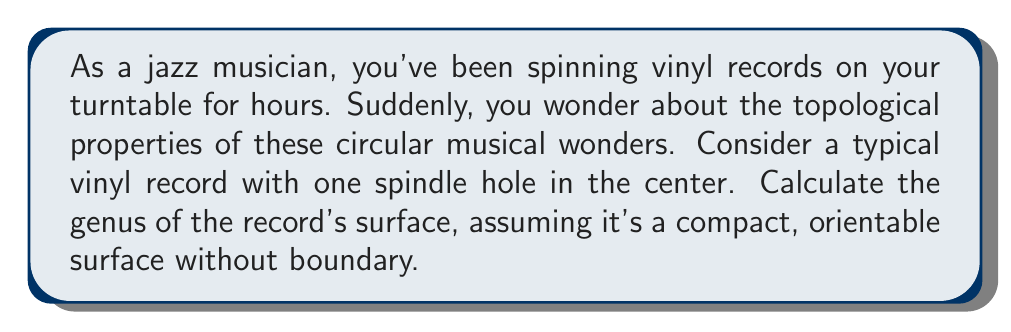Provide a solution to this math problem. To calculate the genus of the vinyl record's surface, we need to consider its topological properties:

1. The record is essentially a flat disk with a hole in the center.

2. In topology, this shape is equivalent to an annulus (a ring-shaped surface).

3. The genus of a surface is the maximum number of simple closed curves that can be drawn on the surface without separating it.

4. For a compact, orientable surface without boundary, the genus $g$ is related to the Euler characteristic $\chi$ by the formula:

   $$\chi = 2 - 2g$$

5. For an annulus, the Euler characteristic is 0. This is because:
   - It has 1 face (the surface itself)
   - It has 2 edges (the outer and inner circles)
   - It has 0 vertices

   $$\chi = V - E + F = 0 - 2 + 1 = -1$$

6. Substituting this into our formula:

   $$0 = 2 - 2g$$

7. Solving for $g$:

   $$2g = 2$$
   $$g = 1$$

Therefore, the genus of the vinyl record's surface is 1.

This means you can draw one simple closed curve (imagine a line from the outer edge to the inner hole and back to the starting point) without separating the surface, but a second such curve would divide the surface into two separate pieces.
Answer: The genus of a vinyl record's surface is 1. 